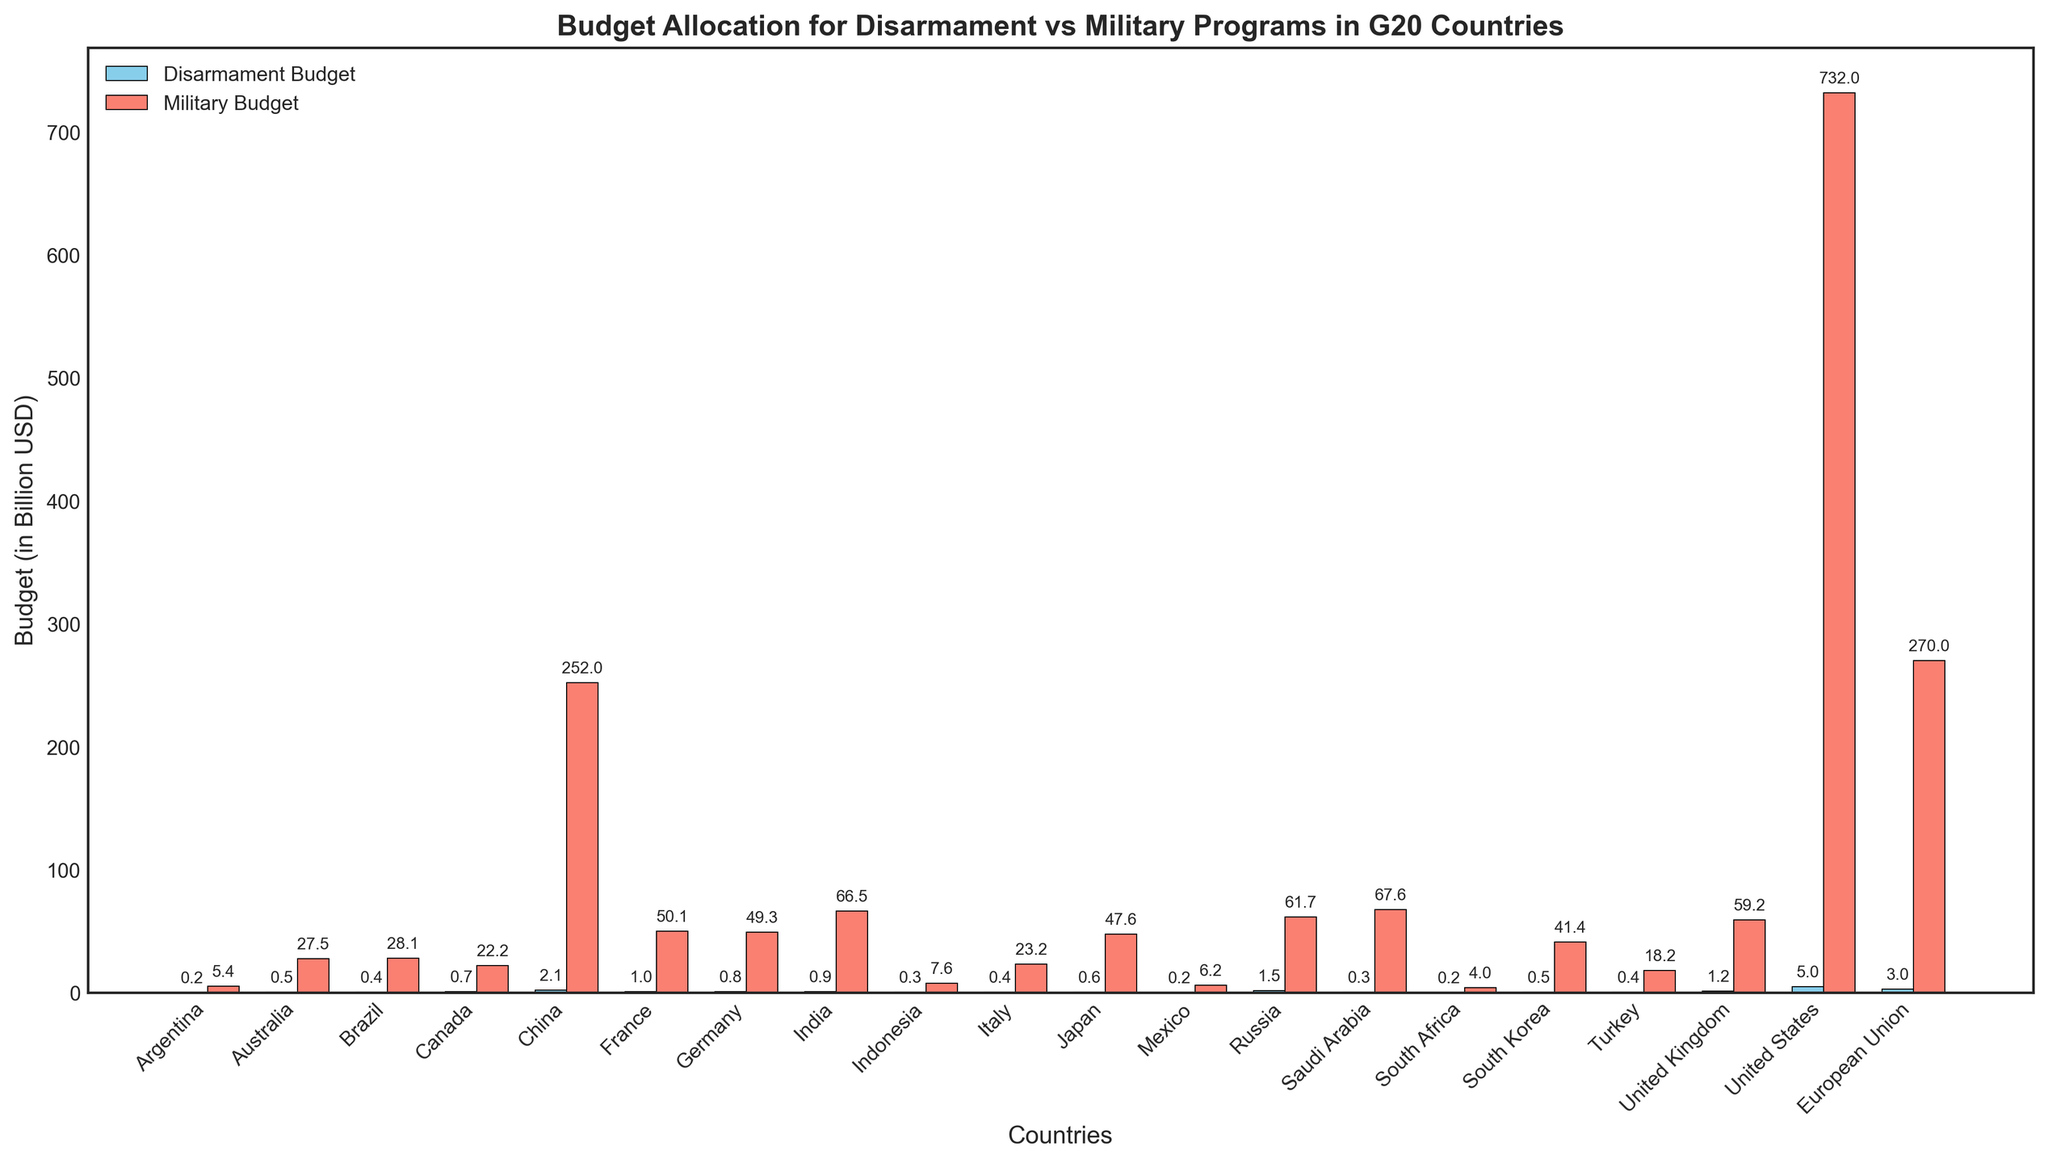What's the total combined budget for Disarmament Programs in all G20 countries? To find the total combined budget for Disarmament Programs, sum the disarmament budgets for all countries. These sums are 0.2+0.5+0.4+0.7+2.1+1.0+0.8+0.9+0.3+0.4+0.6+0.2+1.5+0.3+0.2+0.5+0.4+1.2+5.0+3.0 = 21.2
Answer: 21.2 billion USD Which country has the highest military budget, and what is this amount? To identify the country with the highest military budget, look for the tallest red bar in the chart. The United States has the highest military budget, which is 732.0 billion USD
Answer: United States, 732.0 billion USD Which country has a disarmament budget more than 1 billion USD? Identify the blue bars with heights exceeding 1 billion USD. The countries that qualify are China (2.1 billion USD), France (1 billion USD), Russia (1.5 billion USD), United Kingdom (1.2 billion USD), and European Union (3 billion USD)
Answer: China, France, Russia, United Kingdom, European Union What is the difference between the military budget and the disarmament budget for China? Subtract the disarmament budget from the military budget for China. This difference is 252.0 - 2.1 = 249.9
Answer: 249.9 billion USD How does the military budget of Germany compare to that of Japan? Compare the heights of the red bars for Germany and Japan. Germany's military budget is 49.3 billion USD, whereas Japan's is 47.6 billion USD. Therefore, Germany's military budget is slightly higher
Answer: Germany's military budget is higher What is the average military budget for the European Union, United States, and China? Sum the military budgets for the European Union, United States, and China and then divide by 3. (270.0 + 732.0 + 252.0) / 3 = 1254.0 / 3 = 418.0
Answer: 418.0 billion USD What is the total budget for disarmament programs in Japan, Germany, and Canada combined? Sum the disarmament budgets for Japan, Germany, and Canada. 0.6 + 0.8 + 0.7 = 2.1
Answer: 2.1 billion USD Which country has the smallest disarmament budget, and what is this amount? Identify the shortest blue bar in the chart. Both Mexico, Argentina, and South Africa have the smallest disarmament budgets at 0.2 billion USD
Answer: Mexico, Argentina, South Africa, 0.2 billion USD By how much does the military budget of Russia exceed its disarmament budget? Subtract the disarmament budget from the military budget for Russia. This difference is 61.7 - 1.5 = 60.2
Answer: 60.2 billion USD What is the ratio of the United States military budget to its disarmament budget? Divide the military budget by the disarmament budget for the United States. 732.0 / 5.0 = 146.4
Answer: 146.4:1 